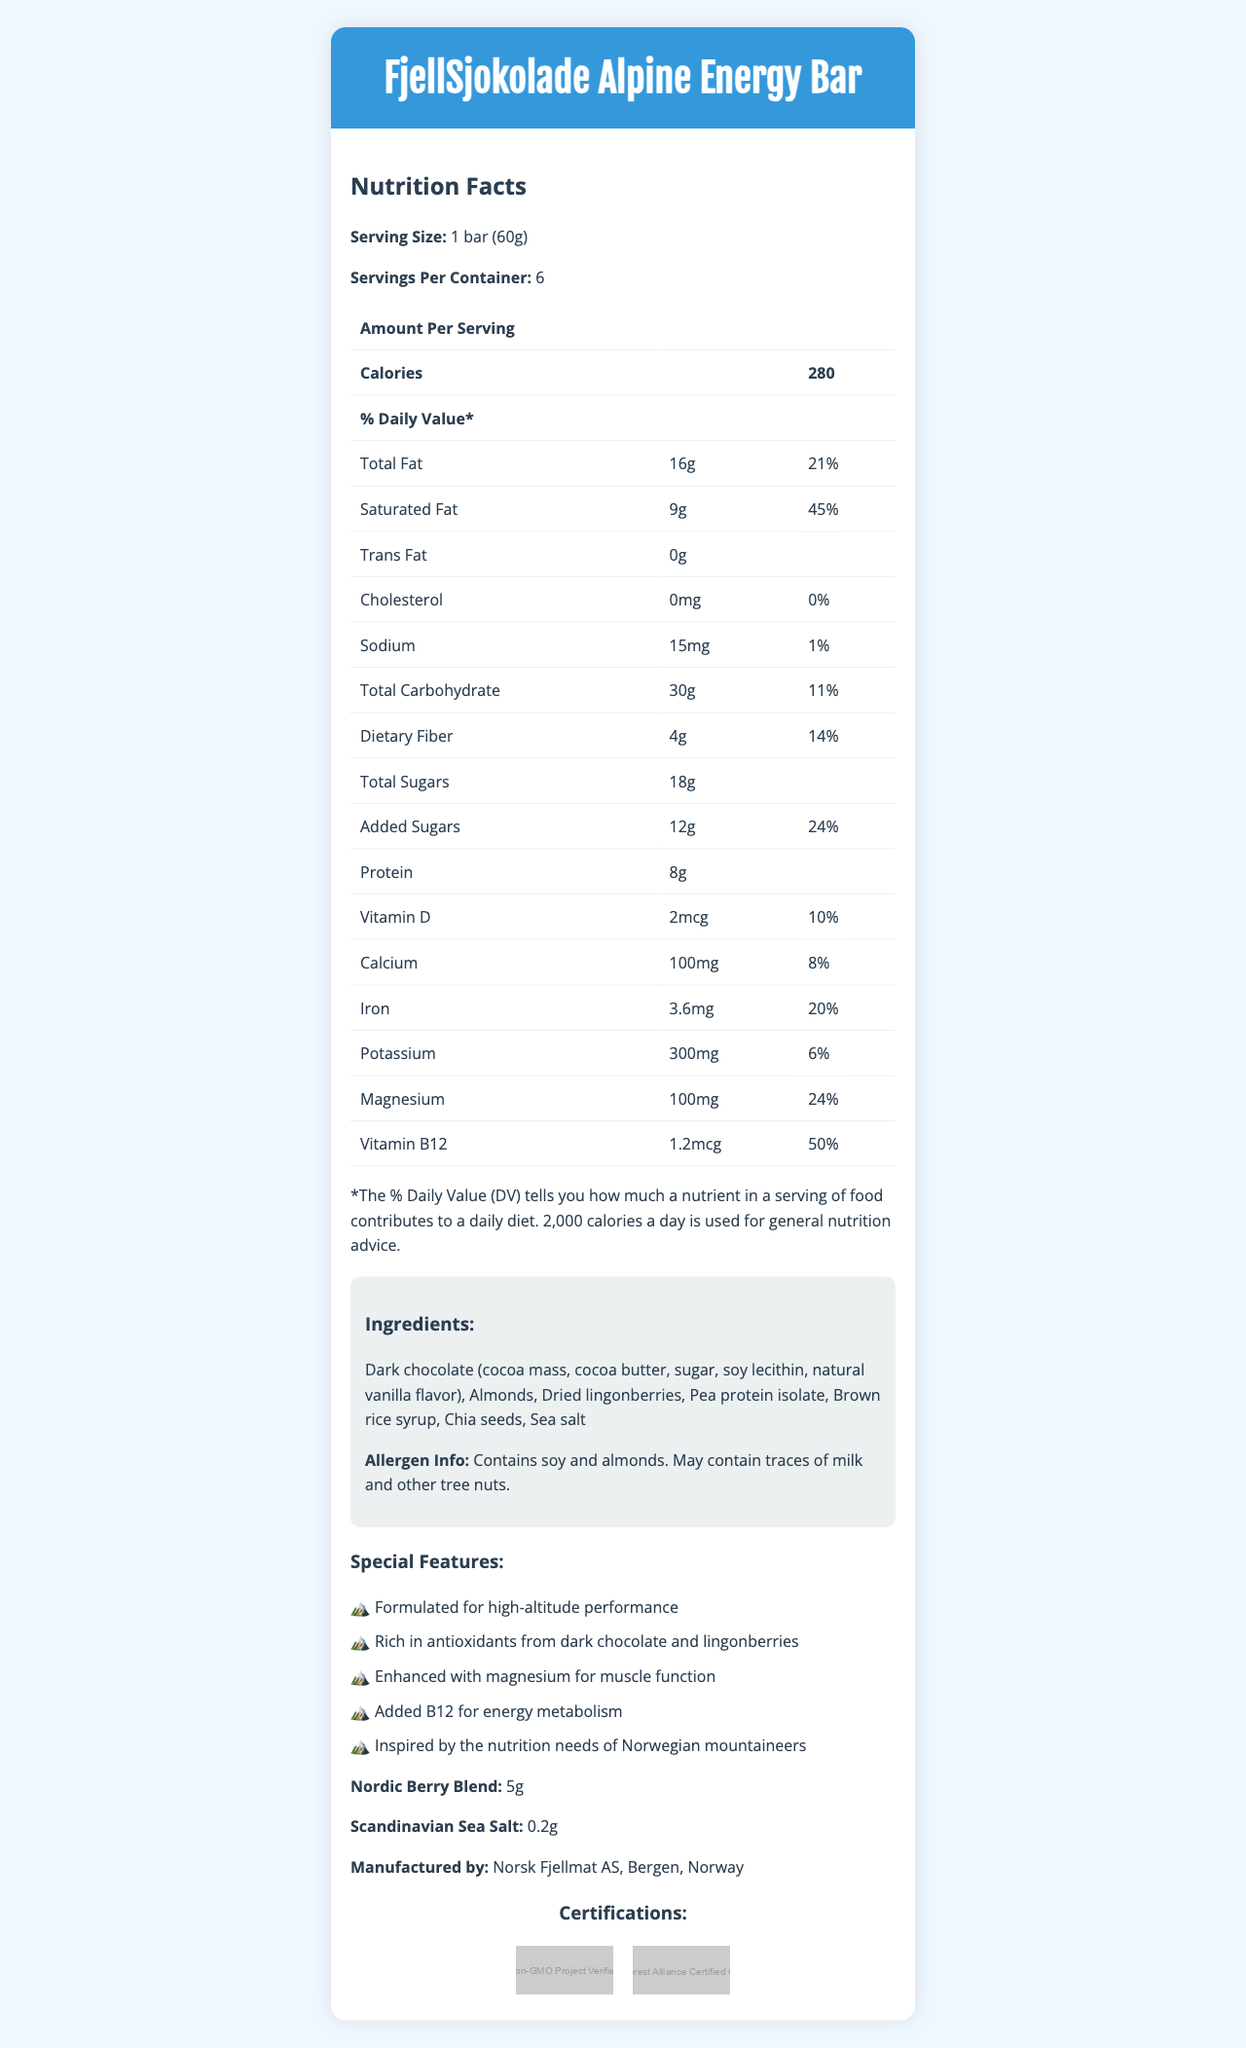what is the serving size of FjellSjokolade Alpine Energy Bar? The serving size is listed under the "Serving Size" section in the document.
Answer: 1 bar (60g) how many servings per container are there? The information is shown under "Servings Per Container".
Answer: 6 what are the total calories per serving? The number of calories per serving is highlighted just below the serving size information.
Answer: 280 what is the amount of protein in one serving? The protein content is listed in the nutrition table under "Amount Per Serving".
Answer: 8g what special features does this product offer? The special features are listed in the "Special Features" section of the document.
Answer: Formulated for high-altitude performance, Rich in antioxidants from dark chocolate and lingonberries, Enhanced with magnesium for muscle function, Added B12 for energy metabolism, Inspired by the nutrition needs of Norwegian mountaineers which of the following vitamins has the highest daily value percentage in one serving?
A. Vitamin D
B. Calcium
C. Iron
D. Vitamin B12 Vitamin B12 has a daily value of 50%, which is higher than the other listed vitamins and minerals.
Answer: D what certifications does this product have? 
A. USDA Organic 
B. Non-GMO Project Verified 
C. Fair Trade Certified 
D. Rainforest Alliance Certified Cocoa The document lists "Non-GMO Project Verified" and "Rainforest Alliance Certified Cocoa" as certifications.
Answer: B, D does this product contain any trans fat? The document states that the Trans Fat amount is 0g.
Answer: No what allergens are present in the FjellSjokolade Alpine Energy Bar? The allergen information section mentions that the product contains soy and almonds and may contain traces of milk and other tree nuts.
Answer: Soy and almonds describe the main features and nutritional information of the FjellSjokolade Alpine Energy Bar. The response includes details on ingredients, nutritional content, certifications, and special features listed in the document, summarizing the main aspects highlighted.
Answer: The FjellSjokolade Alpine Energy Bar is a nutrient-dense chocolate bar formulated for Scandinavian alpine climbing. It contains ingredients like dark chocolate, almonds, dried lingonberries, and pea protein isolate. A single bar has 280 calories, 16g total fat, 8g protein, and various vitamins and minerals, including a high percentage of daily Vitamin B12 and Magnesium. It is non-GMO and uses Rainforest Alliance Certified Cocoa. Special features include high-altitude performance formulation, rich antioxidants, and added B12 for energy metabolism. how much potassium is in each serving? The amount of potassium per serving is specified in the nutrition table.
Answer: 300mg what is the percentage of daily value for magnesium in one serving? The daily value percentage for magnesium is located in the nutrition table.
Answer: 24% can you determine the price of the FjellSjokolade Alpine Energy Bar from the document? The document does not provide any pricing information.
Answer: Not enough information what company manufactures the FjellSjokolade Alpine Energy Bar? The manufacturer's information is given at the bottom of the document.
Answer: Norsk Fjellmat AS, Bergen, Norway what are the added sugars in the bar? The amount of added sugars is specified in the nutrition information.
Answer: 12g 